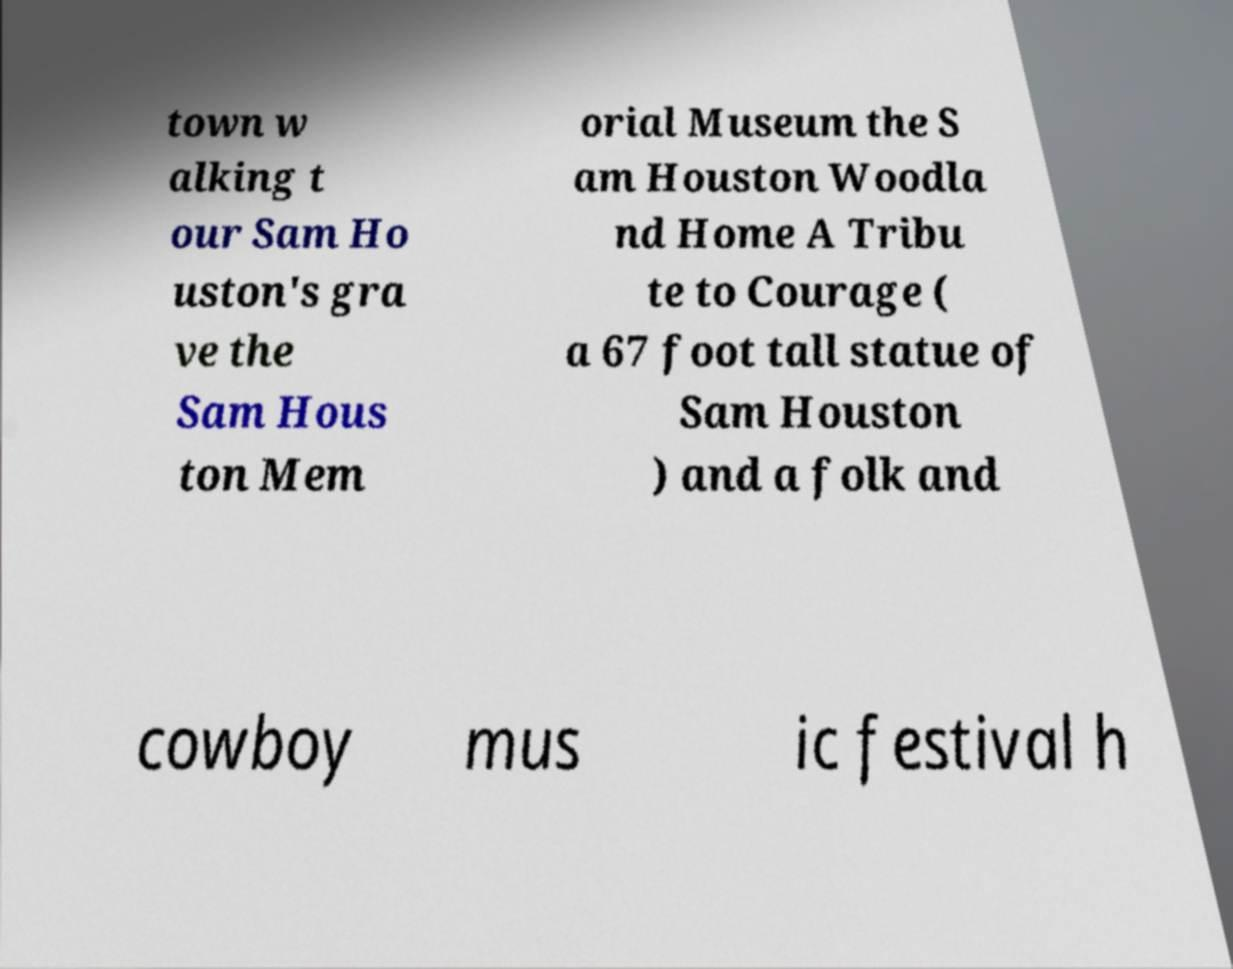Please identify and transcribe the text found in this image. town w alking t our Sam Ho uston's gra ve the Sam Hous ton Mem orial Museum the S am Houston Woodla nd Home A Tribu te to Courage ( a 67 foot tall statue of Sam Houston ) and a folk and cowboy mus ic festival h 